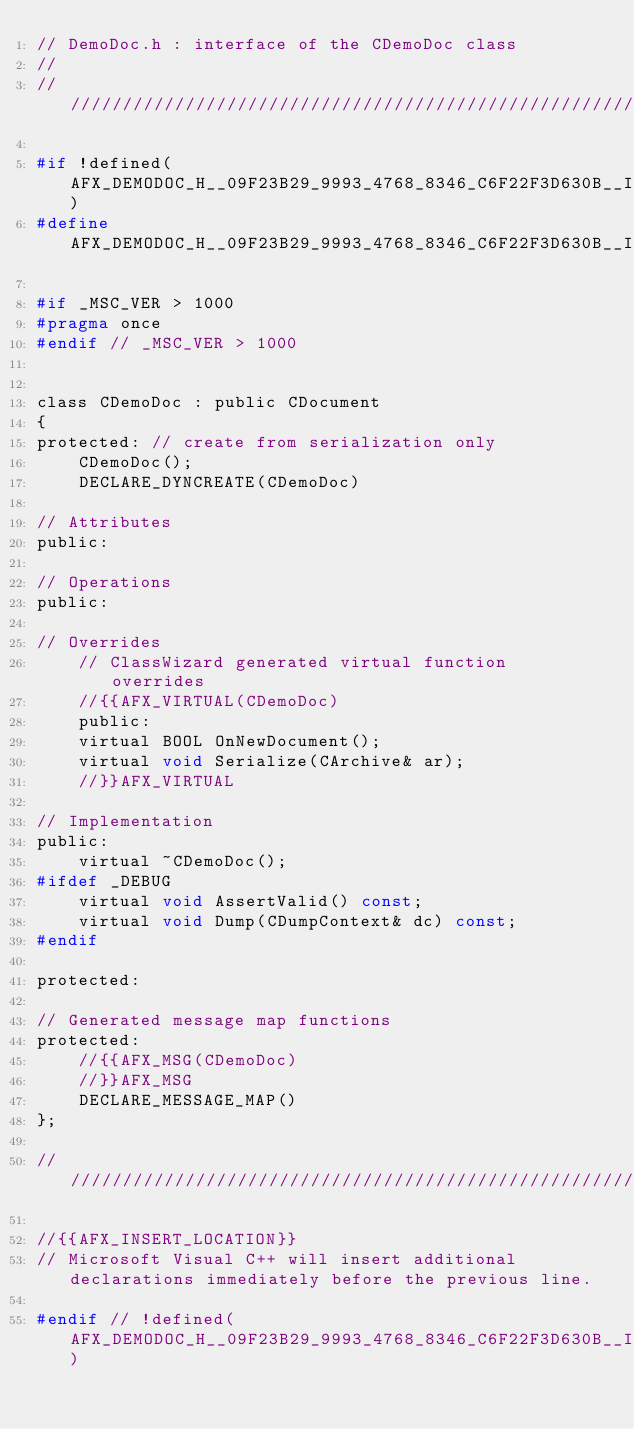<code> <loc_0><loc_0><loc_500><loc_500><_C_>// DemoDoc.h : interface of the CDemoDoc class
//
/////////////////////////////////////////////////////////////////////////////

#if !defined(AFX_DEMODOC_H__09F23B29_9993_4768_8346_C6F22F3D630B__INCLUDED_)
#define AFX_DEMODOC_H__09F23B29_9993_4768_8346_C6F22F3D630B__INCLUDED_

#if _MSC_VER > 1000
#pragma once
#endif // _MSC_VER > 1000


class CDemoDoc : public CDocument
{
protected: // create from serialization only
	CDemoDoc();
	DECLARE_DYNCREATE(CDemoDoc)

// Attributes
public:

// Operations
public:

// Overrides
	// ClassWizard generated virtual function overrides
	//{{AFX_VIRTUAL(CDemoDoc)
	public:
	virtual BOOL OnNewDocument();
	virtual void Serialize(CArchive& ar);
	//}}AFX_VIRTUAL

// Implementation
public:
	virtual ~CDemoDoc();
#ifdef _DEBUG
	virtual void AssertValid() const;
	virtual void Dump(CDumpContext& dc) const;
#endif

protected:

// Generated message map functions
protected:
	//{{AFX_MSG(CDemoDoc)
	//}}AFX_MSG
	DECLARE_MESSAGE_MAP()
};

/////////////////////////////////////////////////////////////////////////////

//{{AFX_INSERT_LOCATION}}
// Microsoft Visual C++ will insert additional declarations immediately before the previous line.

#endif // !defined(AFX_DEMODOC_H__09F23B29_9993_4768_8346_C6F22F3D630B__INCLUDED_)
</code> 